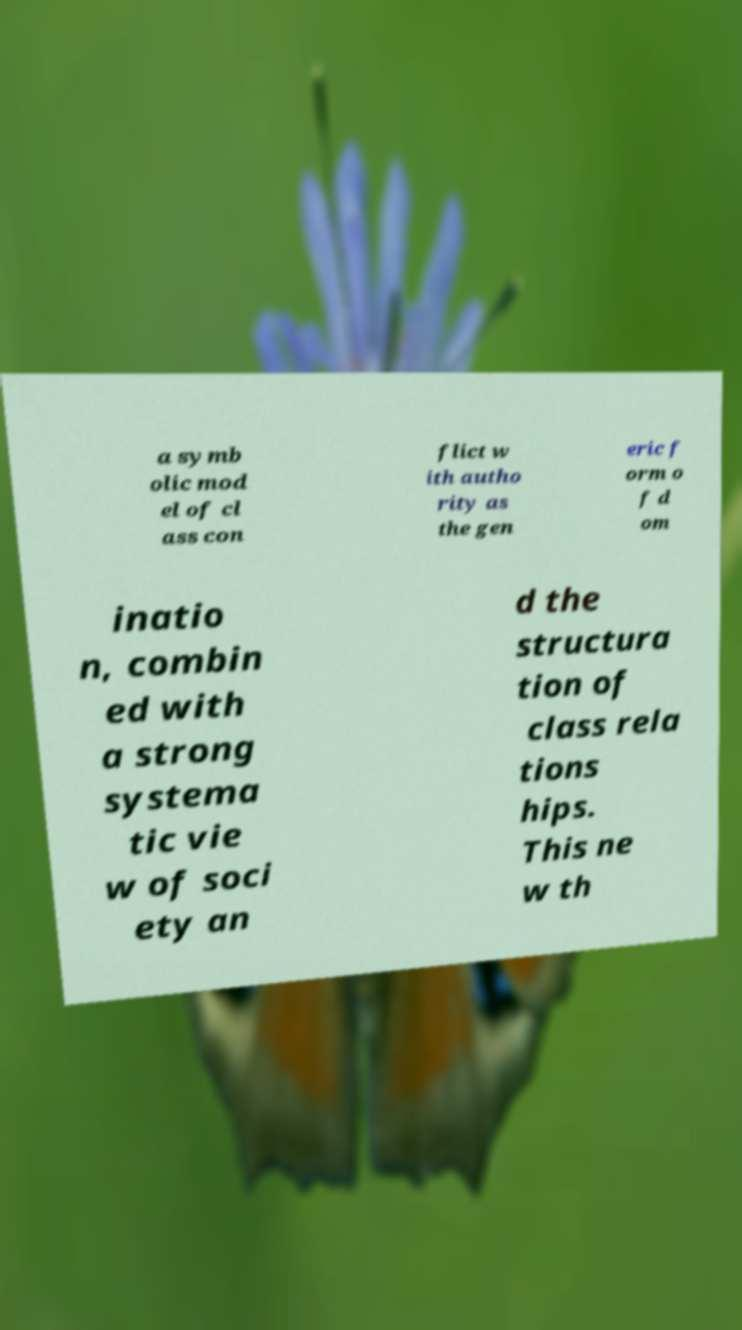Please read and relay the text visible in this image. What does it say? a symb olic mod el of cl ass con flict w ith autho rity as the gen eric f orm o f d om inatio n, combin ed with a strong systema tic vie w of soci ety an d the structura tion of class rela tions hips. This ne w th 